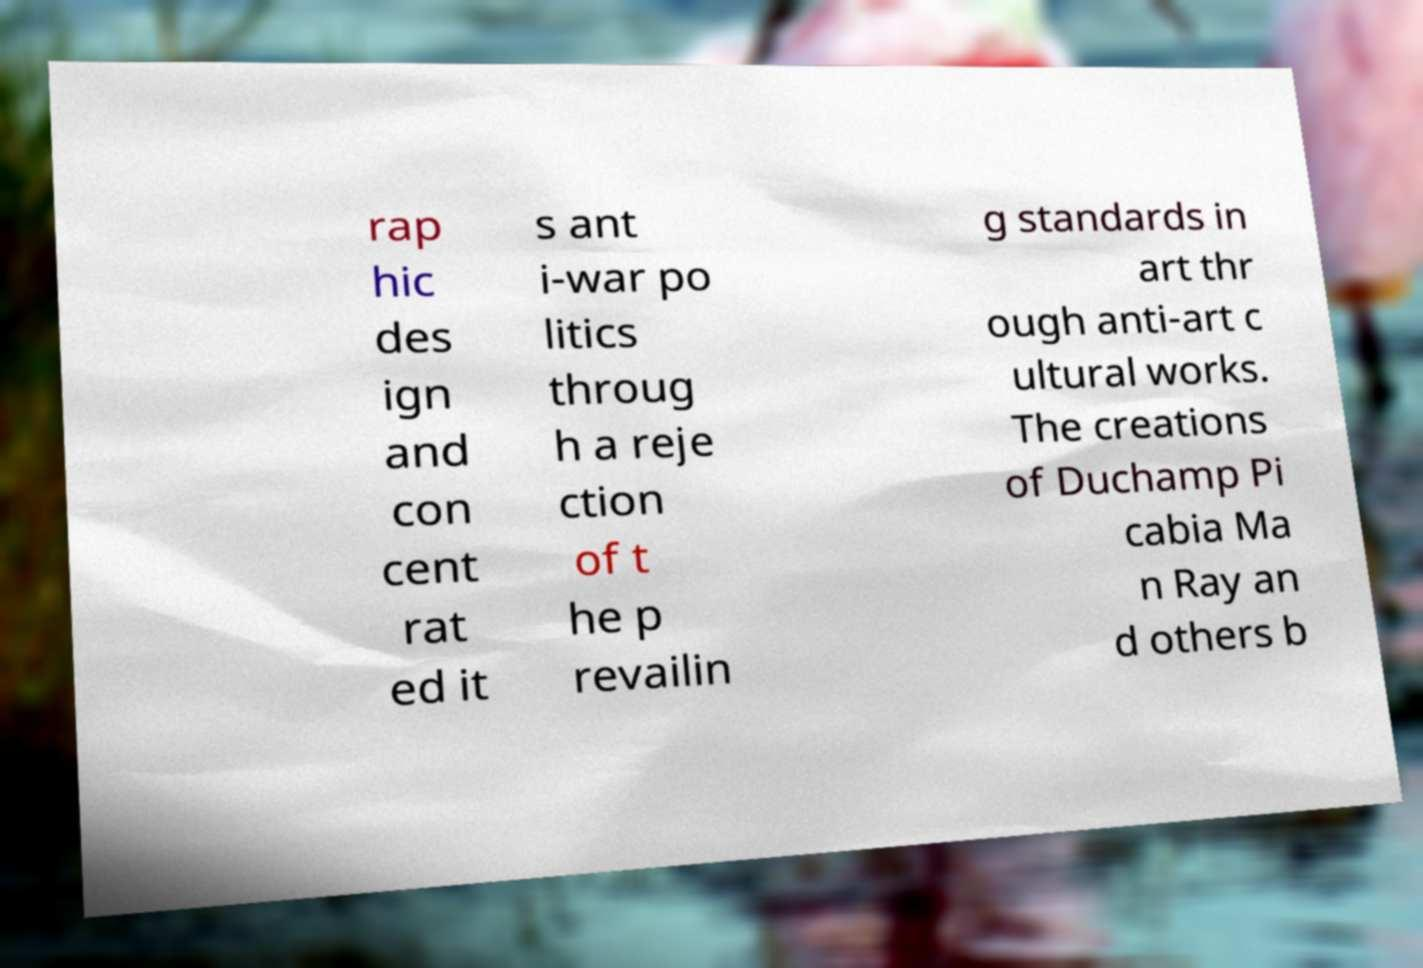Can you read and provide the text displayed in the image?This photo seems to have some interesting text. Can you extract and type it out for me? rap hic des ign and con cent rat ed it s ant i-war po litics throug h a reje ction of t he p revailin g standards in art thr ough anti-art c ultural works. The creations of Duchamp Pi cabia Ma n Ray an d others b 